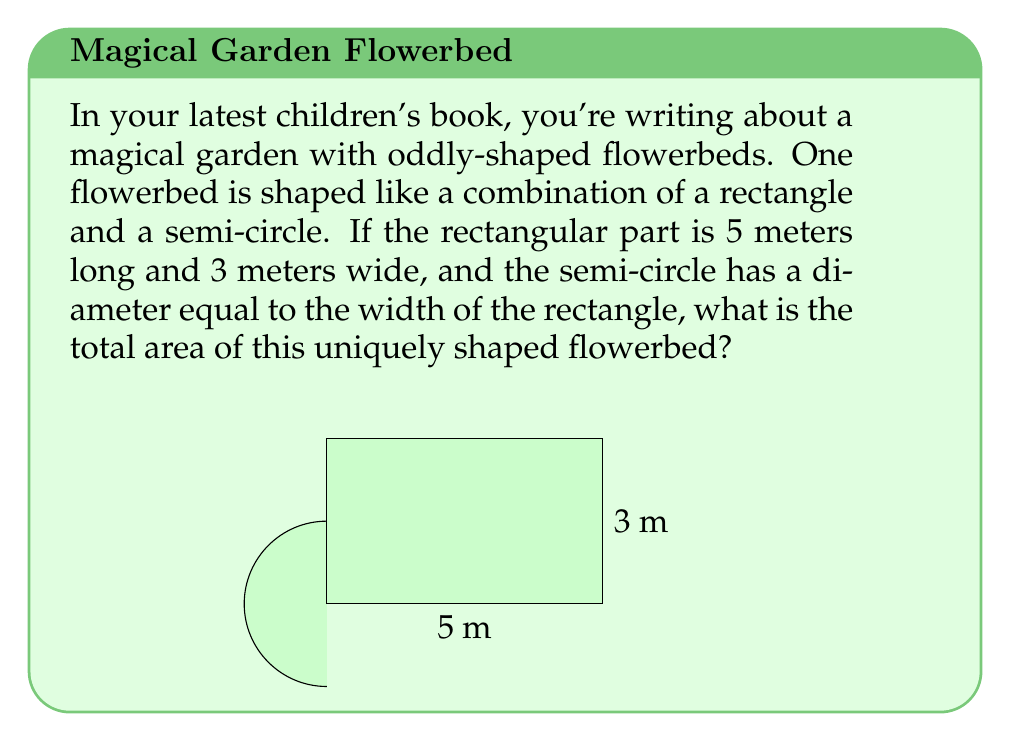Teach me how to tackle this problem. To solve this problem, we need to break it down into two parts: the area of the rectangle and the area of the semi-circle.

1. Area of the rectangle:
   $$ A_{rectangle} = length \times width = 5 \text{ m} \times 3 \text{ m} = 15 \text{ m}^2 $$

2. Area of the semi-circle:
   The diameter of the semi-circle is equal to the width of the rectangle, which is 3 m.
   So, the radius is half of this: $r = 1.5 \text{ m}$
   
   The area of a full circle is $\pi r^2$, so the area of a semi-circle is half of this:
   $$ A_{semi-circle} = \frac{1}{2} \pi r^2 = \frac{1}{2} \pi (1.5 \text{ m})^2 = \frac{9\pi}{4} \text{ m}^2 $$

3. Total area:
   $$ A_{total} = A_{rectangle} + A_{semi-circle} = 15 \text{ m}^2 + \frac{9\pi}{4} \text{ m}^2 $$

4. Simplifying:
   $$ A_{total} = 15 + \frac{9\pi}{4} \text{ m}^2 \approx 22.07 \text{ m}^2 $$
Answer: $15 + \frac{9\pi}{4} \text{ m}^2$ or approximately $22.07 \text{ m}^2$ 